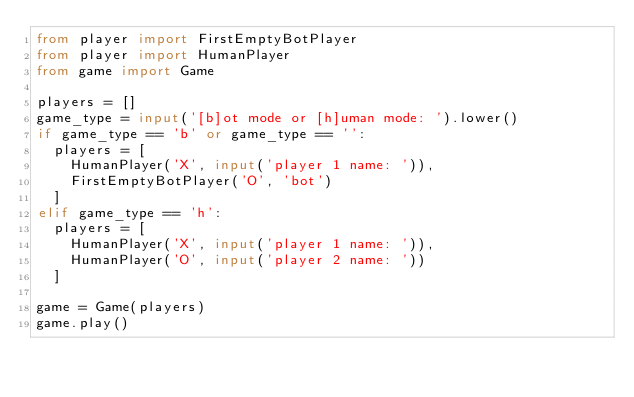<code> <loc_0><loc_0><loc_500><loc_500><_Python_>from player import FirstEmptyBotPlayer
from player import HumanPlayer
from game import Game

players = []
game_type = input('[b]ot mode or [h]uman mode: ').lower()
if game_type == 'b' or game_type == '':
  players = [
    HumanPlayer('X', input('player 1 name: ')),
    FirstEmptyBotPlayer('O', 'bot')
  ]
elif game_type == 'h':
  players = [
    HumanPlayer('X', input('player 1 name: ')),
    HumanPlayer('O', input('player 2 name: '))
  ]

game = Game(players)
game.play()
</code> 